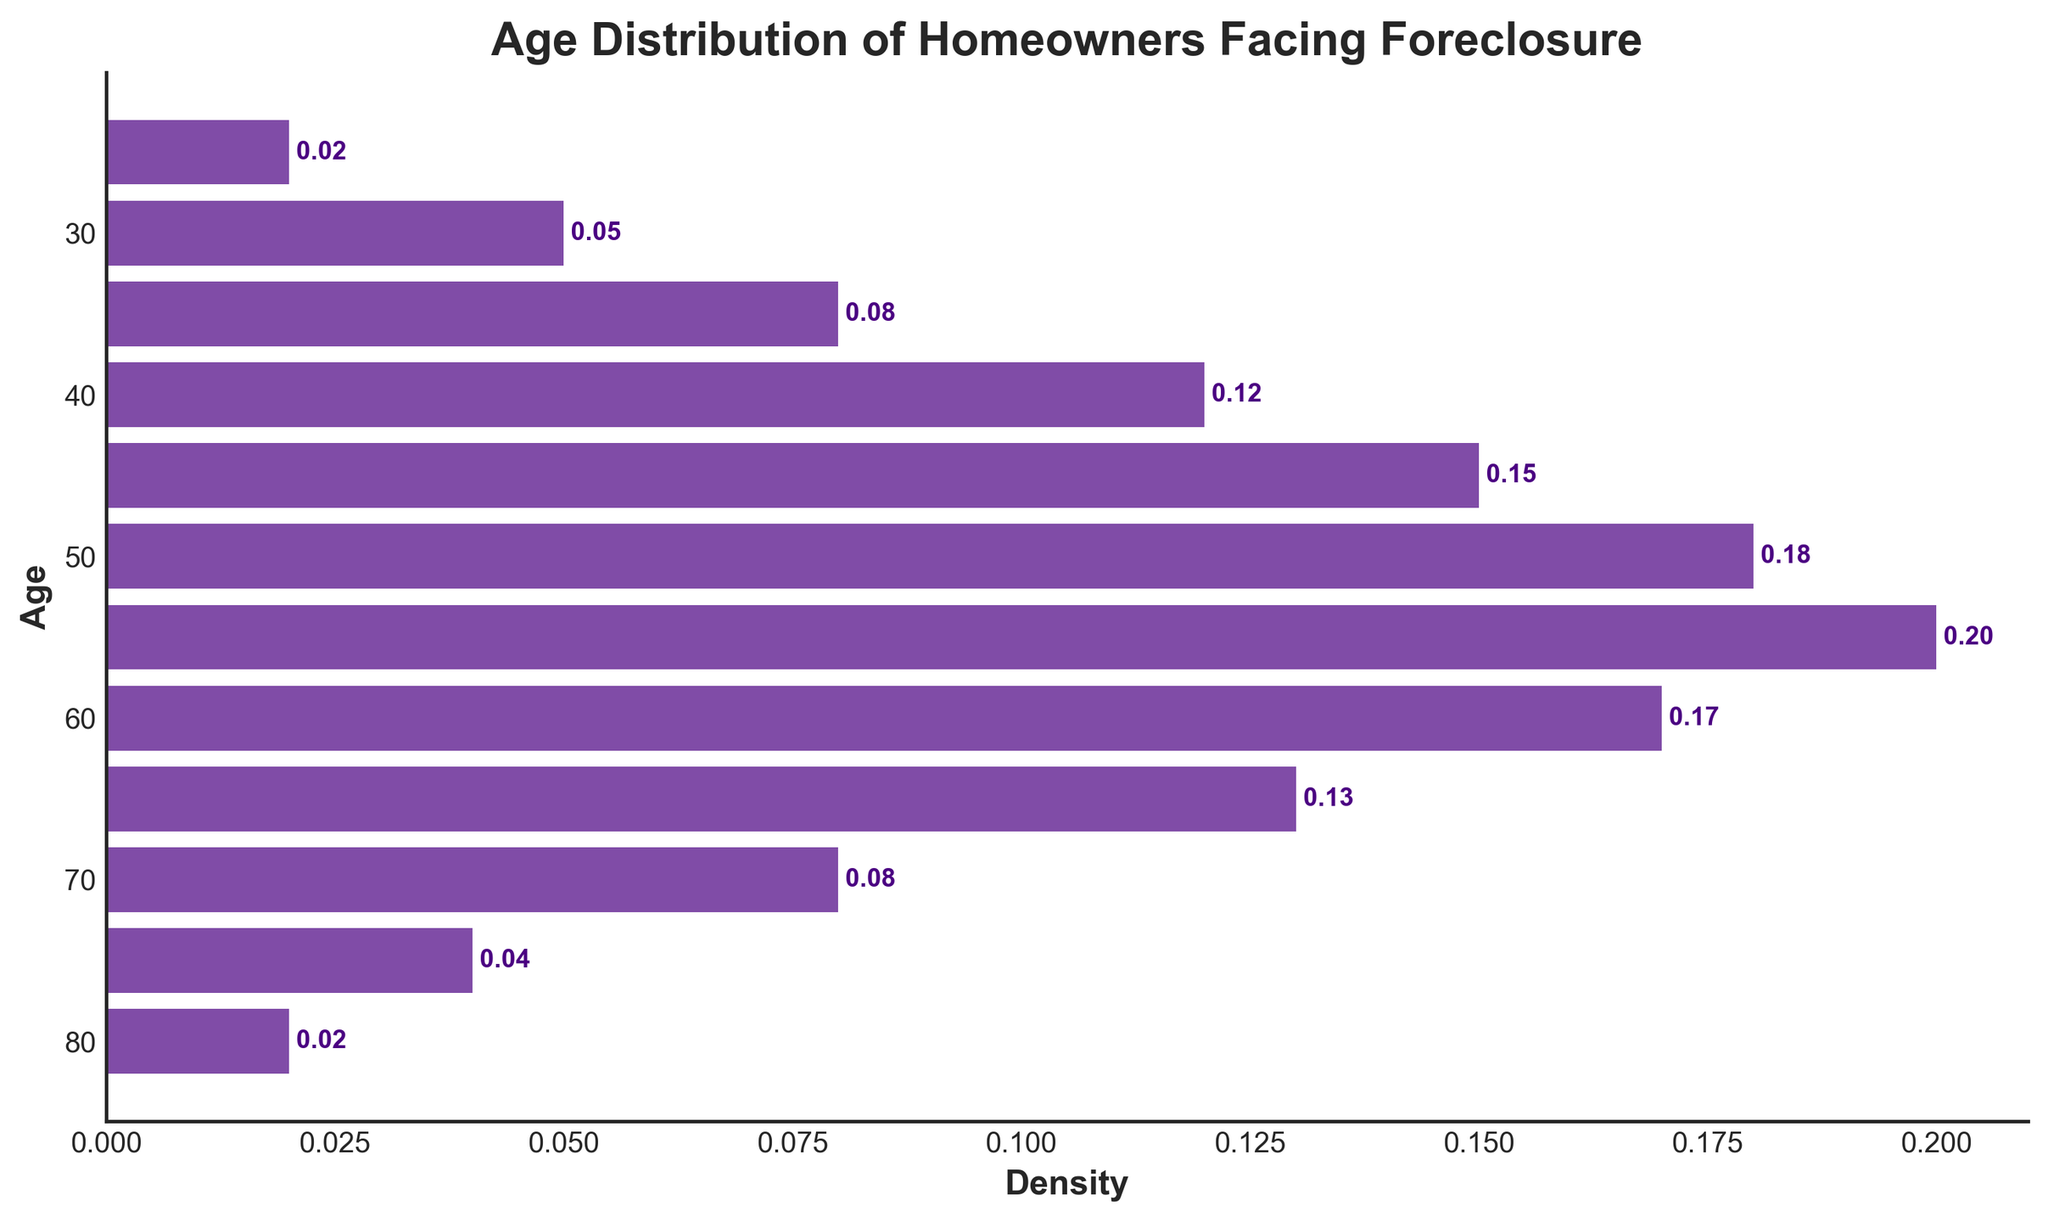What is the title of the figure? The title is usually placed above the figure and describes what the figure is about. In this case, it is "Age Distribution of Homeowners Facing Foreclosure."
Answer: Age Distribution of Homeowners Facing Foreclosure How many age groups are depicted in the figure? To find this, we count all distinct age ticks on the Y-axis. There are age ticks at 25, 30, 35, 40, 45, 50, 55, 60, 65, 70, 75, and 80. Thus, there are 12 age groups.
Answer: 12 Which age group has the highest density? Look at the bars and find the one that extends the furthest to the right, indicating the highest value. The bar at age 55 has the highest density at 0.20.
Answer: 55 What is the average density across all age groups? Sum all the density values and divide by the number of age groups. The sum is (0.02 + 0.05 + 0.08 + 0.12 + 0.15 + 0.18 + 0.20 + 0.17 + 0.13 + 0.08 + 0.04 + 0.02) = 1.24. The average density is 1.24 / 12 = 0.103.
Answer: 0.103 At which age does the density of homeowners facing foreclosure start to decline after peaking? Identify where the highest point is and then observe the subsequent trends. The density peaks at age 55 (0.20), then it starts to decline at age 60 (0.17).
Answer: 60 Which age groups have the same density value, and what is that value? Look at the bars on the figure to see if any two bars have the same length. The bars at ages 25 and 80 both have a density of 0.02.
Answer: 25 and 80, 0.02 How many age groups have a density of 0.10 or higher? Count the bars that extend to 0.10 or beyond on the density axis. These bars are at ages 40 (0.12), 45 (0.15), 50 (0.18), 55 (0.20), and 60 (0.17). So, there are 5 such age groups.
Answer: 5 What is the total density for homeowners aged 45 and above? Sum the densities for age groups 45 and older. Densities are: 0.15 (age 45) + 0.18 (age 50) + 0.20 (age 55) + 0.17 (age 60) + 0.13 (age 65) + 0.08 (age 70) + 0.04 (age 75) + 0.02 (age 80). Total = 0.97.
Answer: 0.97 Which age groups have a higher density than 0.15, and what are those densities? Identify the bars with densities greater than 0.15. The age groups are 50 (0.18), 55 (0.20), and 60 (0.17).
Answer: 50 (0.18), 55 (0.20), 60 (0.17) 